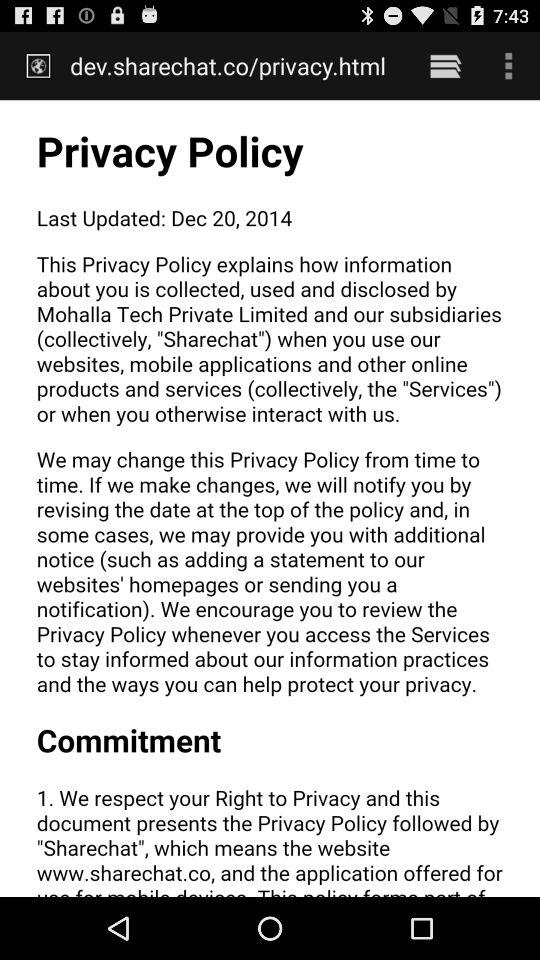The policy is updated on what date? The policy is updated on December 20, 2014. 